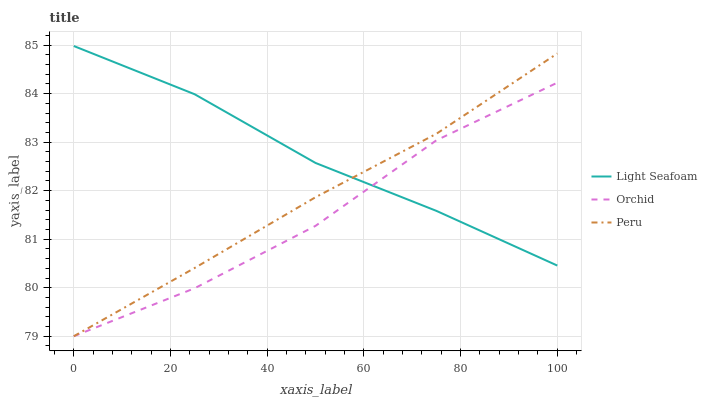Does Orchid have the minimum area under the curve?
Answer yes or no. Yes. Does Light Seafoam have the maximum area under the curve?
Answer yes or no. Yes. Does Peru have the minimum area under the curve?
Answer yes or no. No. Does Peru have the maximum area under the curve?
Answer yes or no. No. Is Peru the smoothest?
Answer yes or no. Yes. Is Orchid the roughest?
Answer yes or no. Yes. Is Orchid the smoothest?
Answer yes or no. No. Is Peru the roughest?
Answer yes or no. No. Does Peru have the lowest value?
Answer yes or no. Yes. Does Light Seafoam have the highest value?
Answer yes or no. Yes. Does Peru have the highest value?
Answer yes or no. No. Does Light Seafoam intersect Orchid?
Answer yes or no. Yes. Is Light Seafoam less than Orchid?
Answer yes or no. No. Is Light Seafoam greater than Orchid?
Answer yes or no. No. 